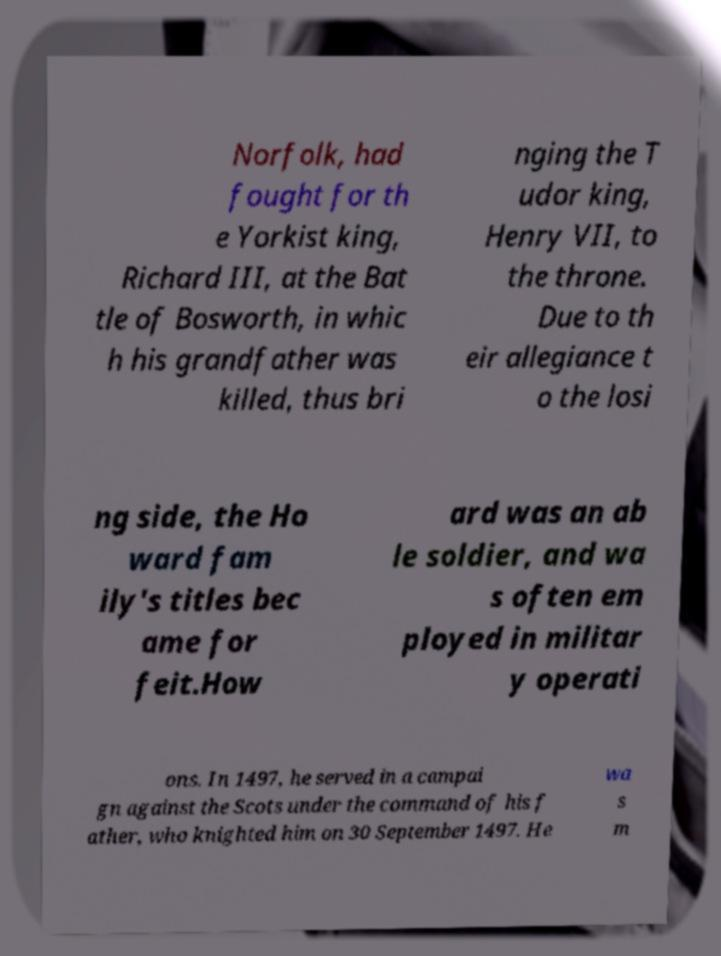Please identify and transcribe the text found in this image. Norfolk, had fought for th e Yorkist king, Richard III, at the Bat tle of Bosworth, in whic h his grandfather was killed, thus bri nging the T udor king, Henry VII, to the throne. Due to th eir allegiance t o the losi ng side, the Ho ward fam ily's titles bec ame for feit.How ard was an ab le soldier, and wa s often em ployed in militar y operati ons. In 1497, he served in a campai gn against the Scots under the command of his f ather, who knighted him on 30 September 1497. He wa s m 